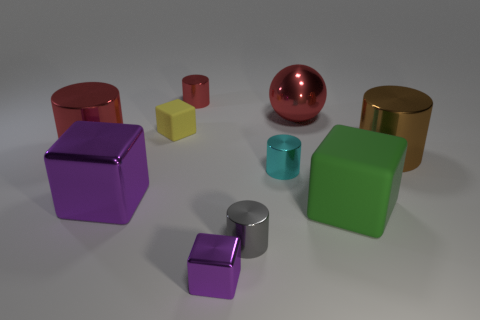There is another metal block that is the same color as the large metallic cube; what size is it? The metal block that shares the color with the large metallic cube is considerably smaller. While the large cube appears to be a centerpiece, the smaller one is akin to a miniature version, which could possibly serve as a paperweight or a decorative object. 